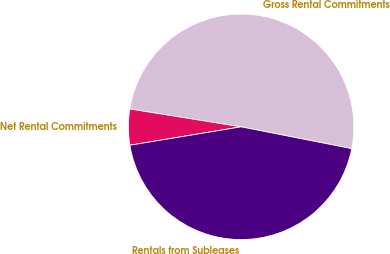Convert chart to OTSL. <chart><loc_0><loc_0><loc_500><loc_500><pie_chart><fcel>Gross Rental Commitments<fcel>Net Rental Commitments<fcel>Rentals from Subleases<nl><fcel>50.57%<fcel>5.14%<fcel>44.29%<nl></chart> 